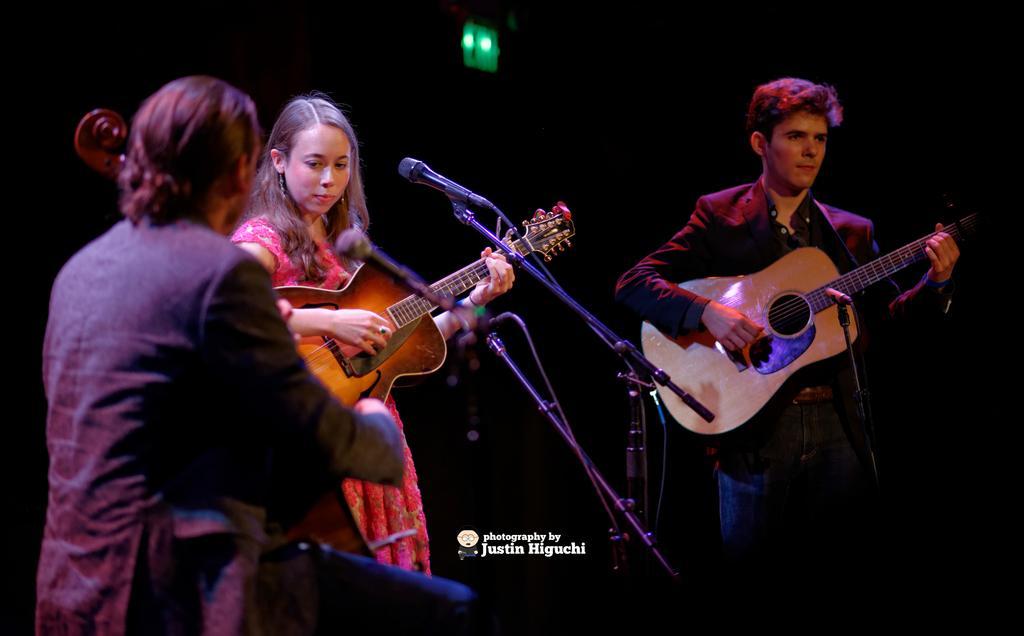Please provide a concise description of this image. There are two men playing guitar and one lady with pink frock is also playing a guitar. There are two mics with the stands. The man at the right side is wearing a black jacket. 